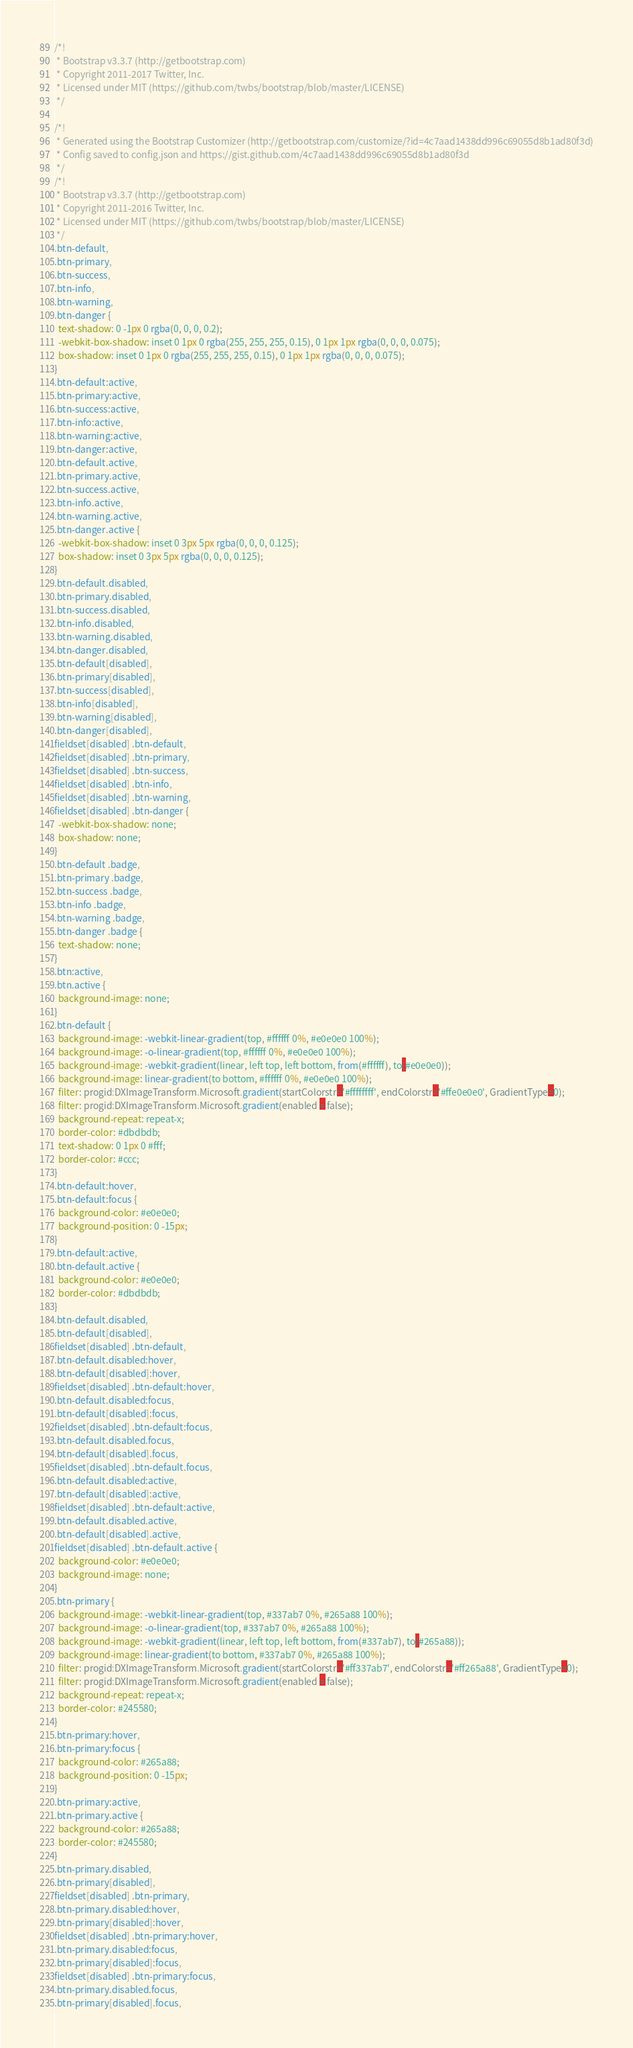Convert code to text. <code><loc_0><loc_0><loc_500><loc_500><_CSS_>/*!
 * Bootstrap v3.3.7 (http://getbootstrap.com)
 * Copyright 2011-2017 Twitter, Inc.
 * Licensed under MIT (https://github.com/twbs/bootstrap/blob/master/LICENSE)
 */

/*!
 * Generated using the Bootstrap Customizer (http://getbootstrap.com/customize/?id=4c7aad1438dd996c69055d8b1ad80f3d)
 * Config saved to config.json and https://gist.github.com/4c7aad1438dd996c69055d8b1ad80f3d
 */
/*!
 * Bootstrap v3.3.7 (http://getbootstrap.com)
 * Copyright 2011-2016 Twitter, Inc.
 * Licensed under MIT (https://github.com/twbs/bootstrap/blob/master/LICENSE)
 */
.btn-default,
.btn-primary,
.btn-success,
.btn-info,
.btn-warning,
.btn-danger {
  text-shadow: 0 -1px 0 rgba(0, 0, 0, 0.2);
  -webkit-box-shadow: inset 0 1px 0 rgba(255, 255, 255, 0.15), 0 1px 1px rgba(0, 0, 0, 0.075);
  box-shadow: inset 0 1px 0 rgba(255, 255, 255, 0.15), 0 1px 1px rgba(0, 0, 0, 0.075);
}
.btn-default:active,
.btn-primary:active,
.btn-success:active,
.btn-info:active,
.btn-warning:active,
.btn-danger:active,
.btn-default.active,
.btn-primary.active,
.btn-success.active,
.btn-info.active,
.btn-warning.active,
.btn-danger.active {
  -webkit-box-shadow: inset 0 3px 5px rgba(0, 0, 0, 0.125);
  box-shadow: inset 0 3px 5px rgba(0, 0, 0, 0.125);
}
.btn-default.disabled,
.btn-primary.disabled,
.btn-success.disabled,
.btn-info.disabled,
.btn-warning.disabled,
.btn-danger.disabled,
.btn-default[disabled],
.btn-primary[disabled],
.btn-success[disabled],
.btn-info[disabled],
.btn-warning[disabled],
.btn-danger[disabled],
fieldset[disabled] .btn-default,
fieldset[disabled] .btn-primary,
fieldset[disabled] .btn-success,
fieldset[disabled] .btn-info,
fieldset[disabled] .btn-warning,
fieldset[disabled] .btn-danger {
  -webkit-box-shadow: none;
  box-shadow: none;
}
.btn-default .badge,
.btn-primary .badge,
.btn-success .badge,
.btn-info .badge,
.btn-warning .badge,
.btn-danger .badge {
  text-shadow: none;
}
.btn:active,
.btn.active {
  background-image: none;
}
.btn-default {
  background-image: -webkit-linear-gradient(top, #ffffff 0%, #e0e0e0 100%);
  background-image: -o-linear-gradient(top, #ffffff 0%, #e0e0e0 100%);
  background-image: -webkit-gradient(linear, left top, left bottom, from(#ffffff), to(#e0e0e0));
  background-image: linear-gradient(to bottom, #ffffff 0%, #e0e0e0 100%);
  filter: progid:DXImageTransform.Microsoft.gradient(startColorstr='#ffffffff', endColorstr='#ffe0e0e0', GradientType=0);
  filter: progid:DXImageTransform.Microsoft.gradient(enabled = false);
  background-repeat: repeat-x;
  border-color: #dbdbdb;
  text-shadow: 0 1px 0 #fff;
  border-color: #ccc;
}
.btn-default:hover,
.btn-default:focus {
  background-color: #e0e0e0;
  background-position: 0 -15px;
}
.btn-default:active,
.btn-default.active {
  background-color: #e0e0e0;
  border-color: #dbdbdb;
}
.btn-default.disabled,
.btn-default[disabled],
fieldset[disabled] .btn-default,
.btn-default.disabled:hover,
.btn-default[disabled]:hover,
fieldset[disabled] .btn-default:hover,
.btn-default.disabled:focus,
.btn-default[disabled]:focus,
fieldset[disabled] .btn-default:focus,
.btn-default.disabled.focus,
.btn-default[disabled].focus,
fieldset[disabled] .btn-default.focus,
.btn-default.disabled:active,
.btn-default[disabled]:active,
fieldset[disabled] .btn-default:active,
.btn-default.disabled.active,
.btn-default[disabled].active,
fieldset[disabled] .btn-default.active {
  background-color: #e0e0e0;
  background-image: none;
}
.btn-primary {
  background-image: -webkit-linear-gradient(top, #337ab7 0%, #265a88 100%);
  background-image: -o-linear-gradient(top, #337ab7 0%, #265a88 100%);
  background-image: -webkit-gradient(linear, left top, left bottom, from(#337ab7), to(#265a88));
  background-image: linear-gradient(to bottom, #337ab7 0%, #265a88 100%);
  filter: progid:DXImageTransform.Microsoft.gradient(startColorstr='#ff337ab7', endColorstr='#ff265a88', GradientType=0);
  filter: progid:DXImageTransform.Microsoft.gradient(enabled = false);
  background-repeat: repeat-x;
  border-color: #245580;
}
.btn-primary:hover,
.btn-primary:focus {
  background-color: #265a88;
  background-position: 0 -15px;
}
.btn-primary:active,
.btn-primary.active {
  background-color: #265a88;
  border-color: #245580;
}
.btn-primary.disabled,
.btn-primary[disabled],
fieldset[disabled] .btn-primary,
.btn-primary.disabled:hover,
.btn-primary[disabled]:hover,
fieldset[disabled] .btn-primary:hover,
.btn-primary.disabled:focus,
.btn-primary[disabled]:focus,
fieldset[disabled] .btn-primary:focus,
.btn-primary.disabled.focus,
.btn-primary[disabled].focus,</code> 